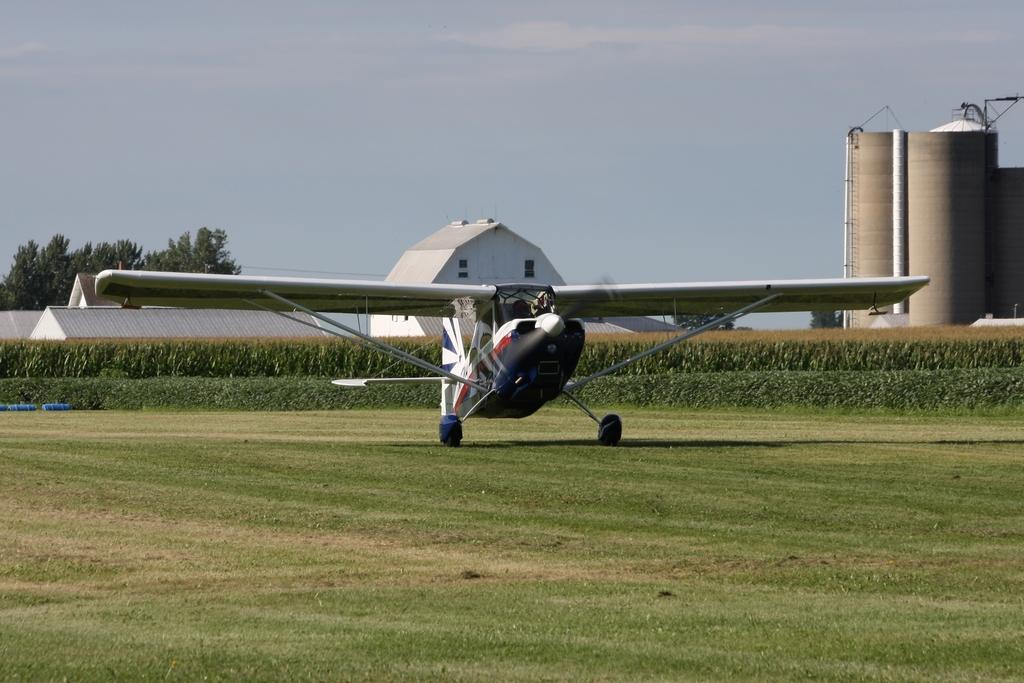What is the main subject of the image? The main subject of the image is an airplane on the ground. What type of natural elements can be seen in the image? Plants and trees are visible in the image. What type of man-made structures can be seen in the image? Houses and buildings are visible in the image. What is visible in the background of the image? The sky is visible in the background of the image. What can be observed in the sky? Clouds are present in the sky. What type of care is the airplane receiving in the image? There is no indication in the image that the airplane is receiving any care. What type of seed is visible in the image? There is no seed present in the image. 